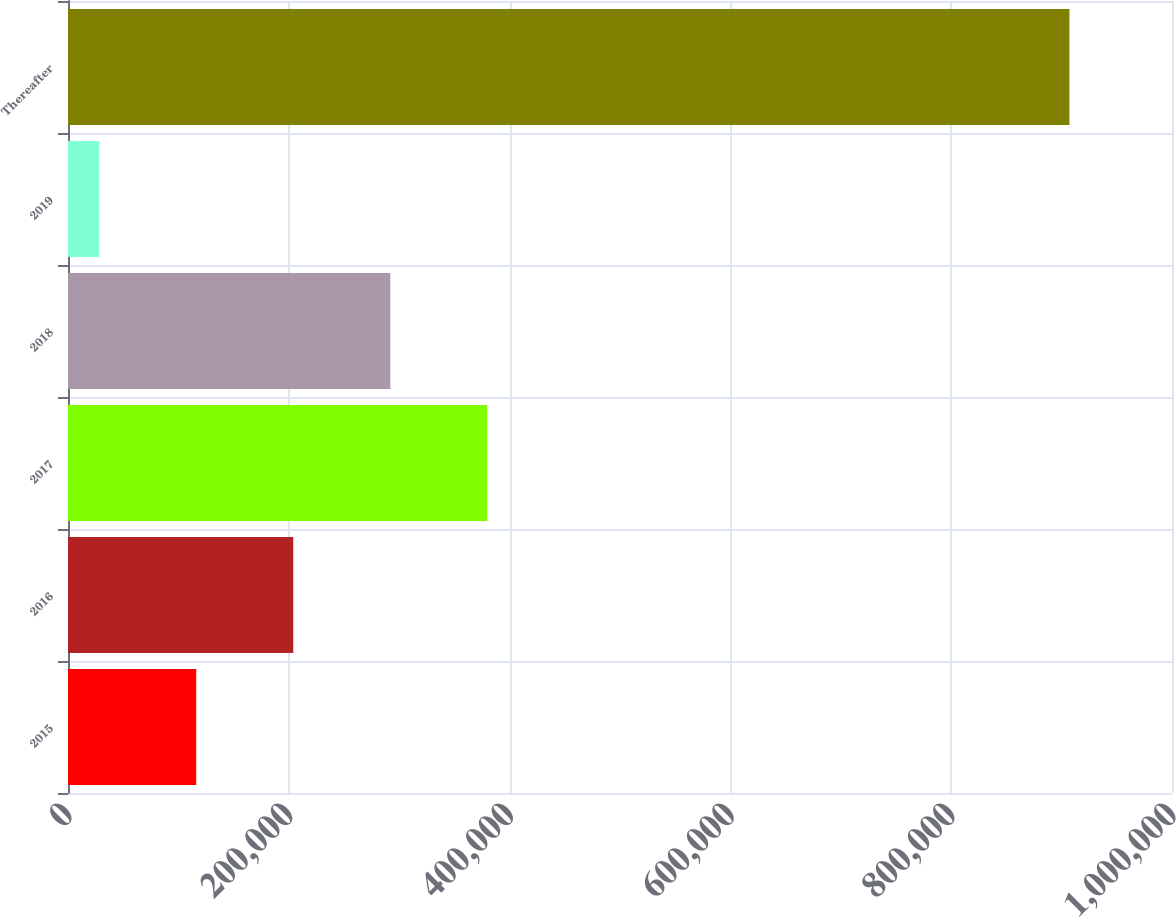<chart> <loc_0><loc_0><loc_500><loc_500><bar_chart><fcel>2015<fcel>2016<fcel>2017<fcel>2018<fcel>2019<fcel>Thereafter<nl><fcel>116150<fcel>204035<fcel>379804<fcel>291919<fcel>28266<fcel>907110<nl></chart> 